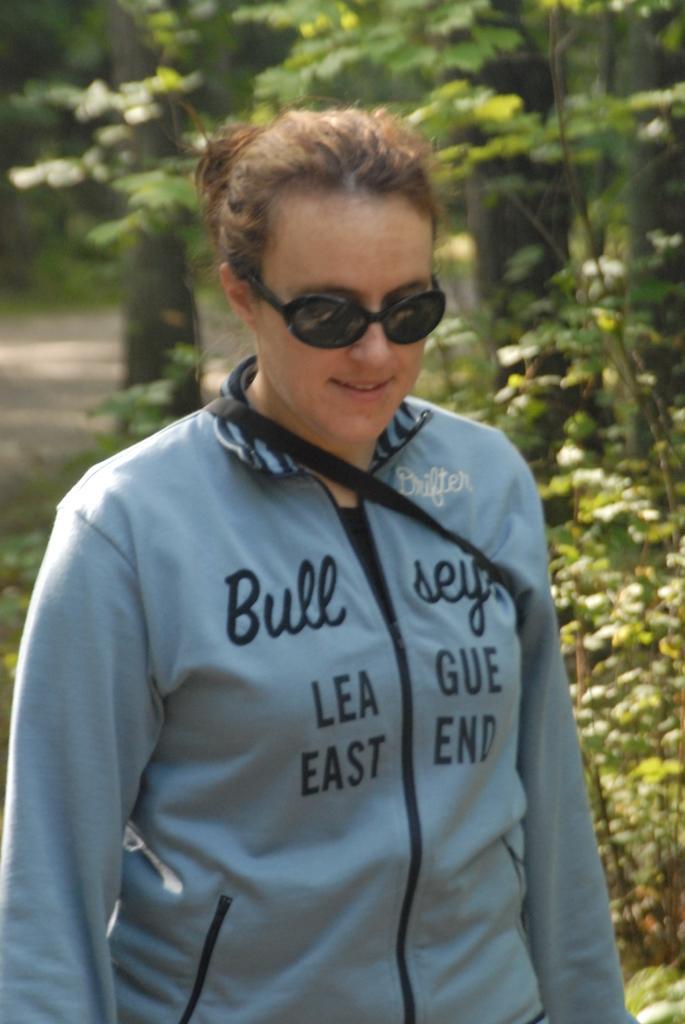Describe this image in one or two sentences. In this picture we can see a woman, she is wearing a goggles and in the background we can see trees on the ground. 